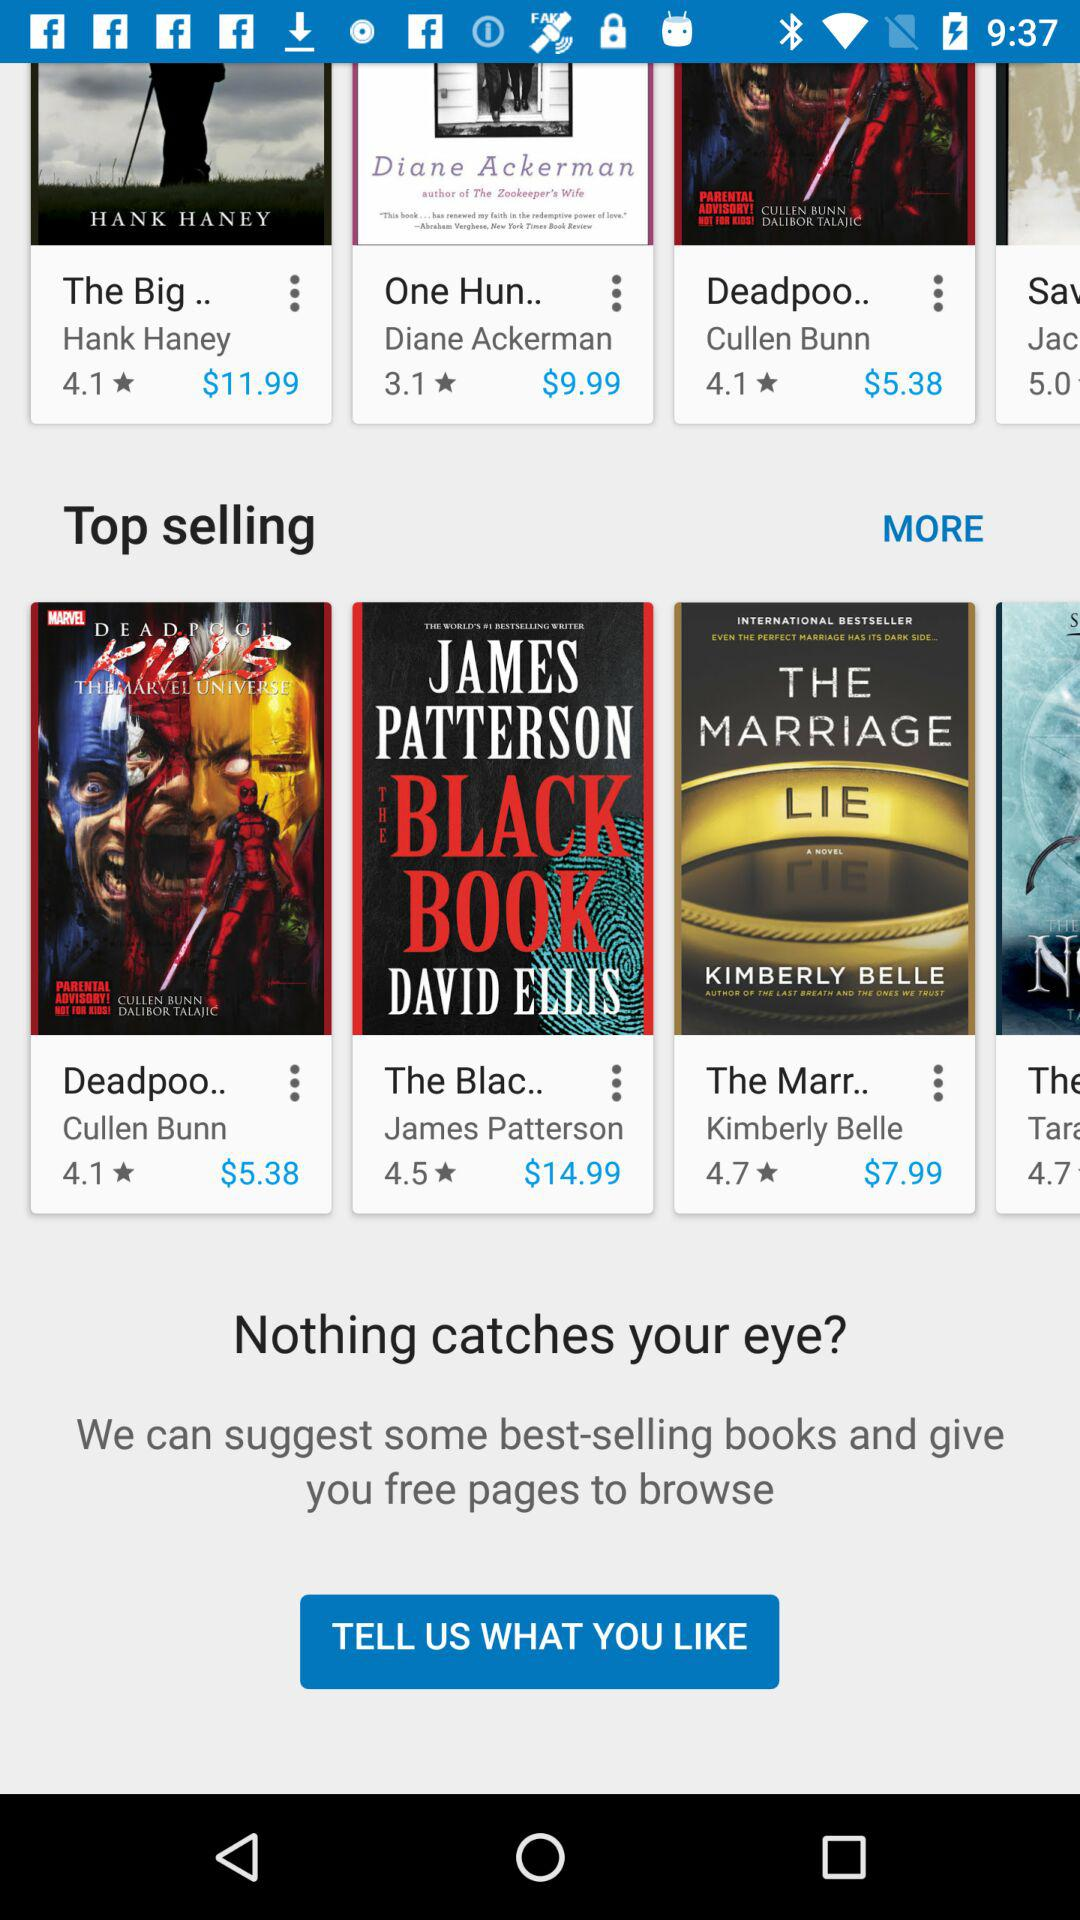What is the price of the book "One Hun.."? The price is $9.99. 